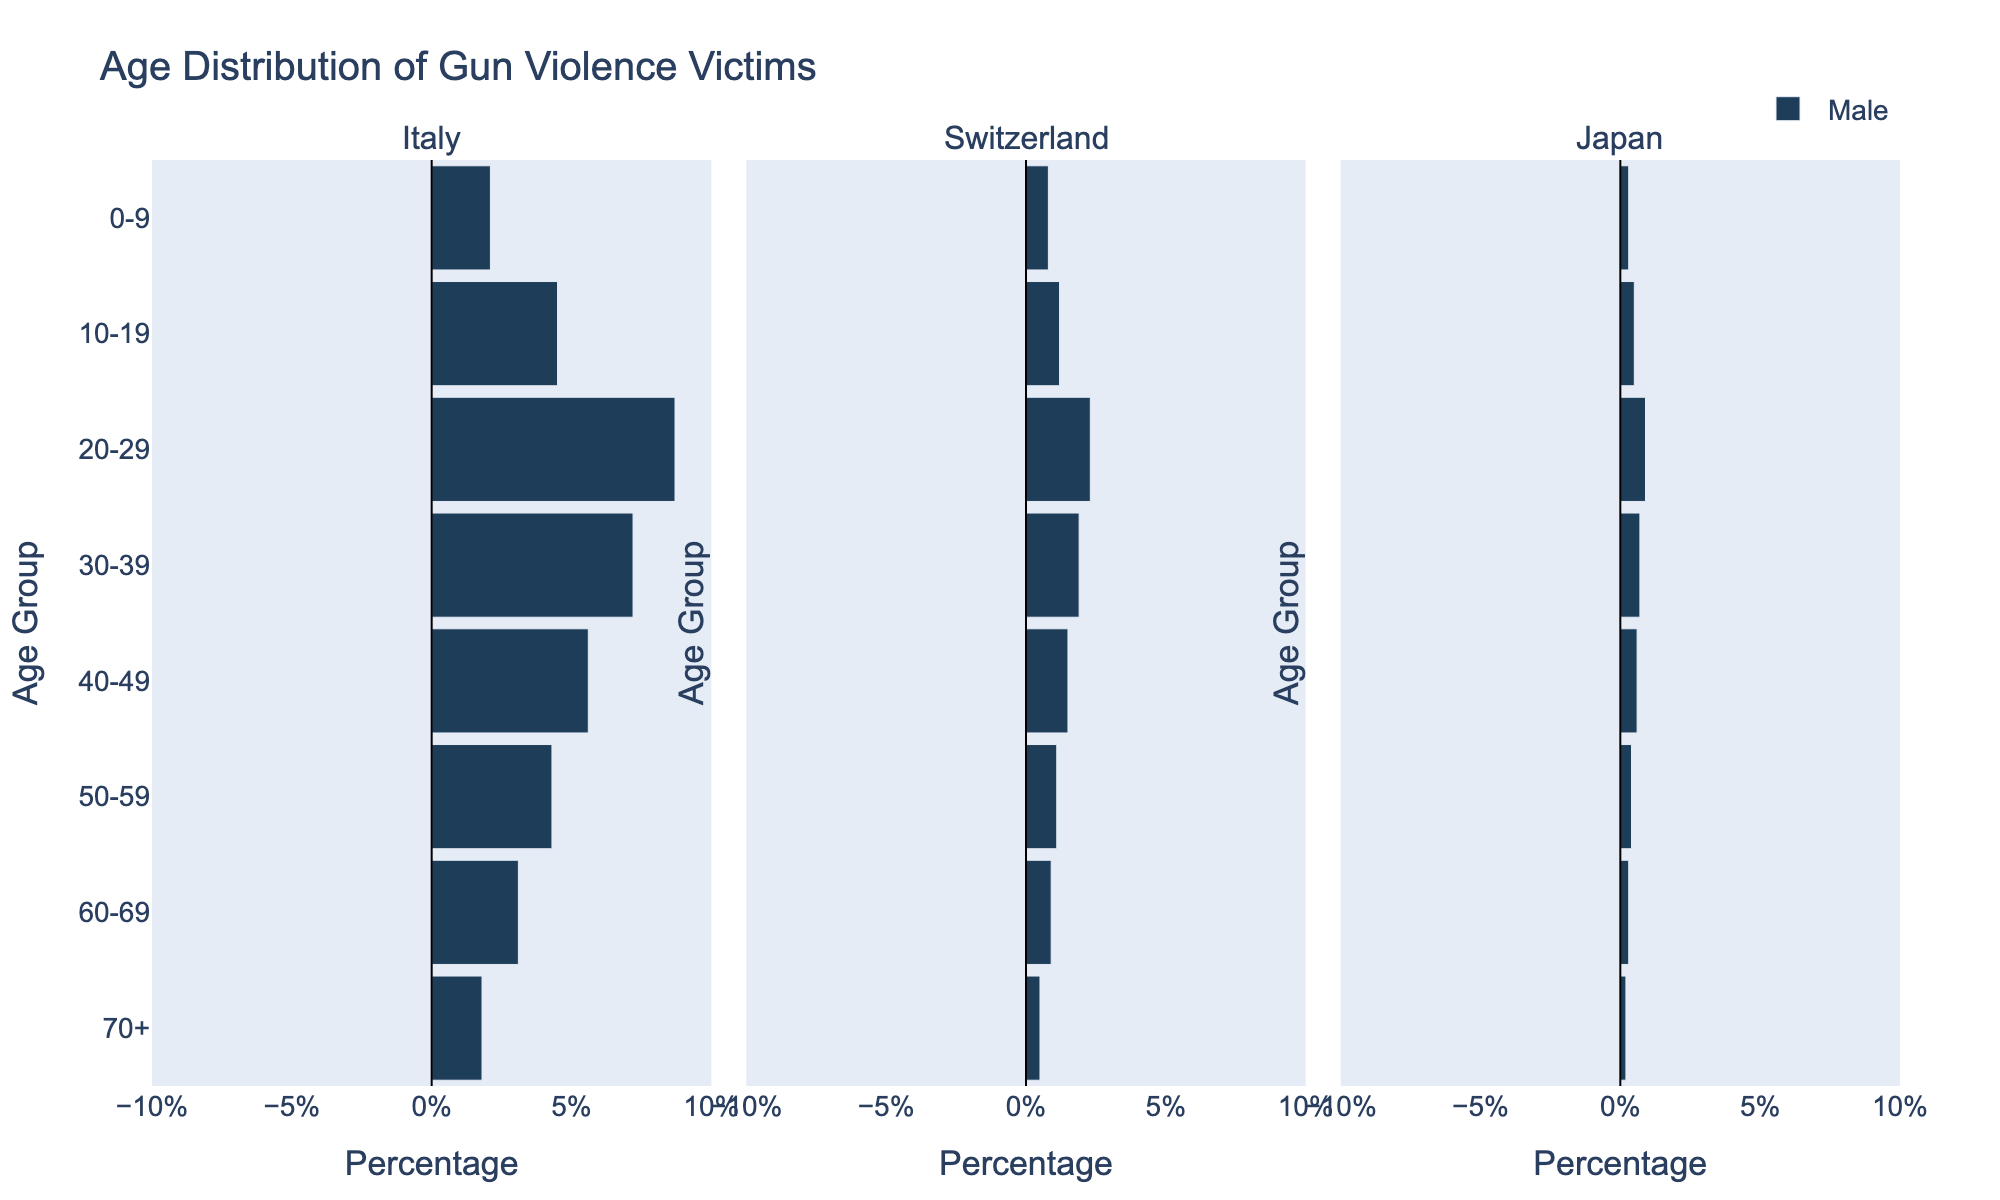What is the title of the figure? The title is often placed at the top of the figure. It provides a summary of what the visual information represents. In this case, it states the age distribution of gun violence victims.
Answer: Age Distribution of Gun Violence Victims Which age group has the highest percentage of male gun violence victims in Italy? Look at the bars on the left side of the Italy subplot. Identify the longest bar to determine the age group with the highest percentage of male victims.
Answer: 20-29 How do the percentages of male gun violence victims in Japan and Switzerland in the 50-59 age group compare? Compare the length of the bars on the left side of the Japan and Switzerland subplots for the 50-59 age group to see which is longer.
Answer: Japan has a lower percentage (0.4%) than Switzerland (1.1%) What is the total percentage of gun violence victims aged 0-9 for both males and females in Italy? Look at the length of the bars for both males and females in the Italy subplot for the age group 0-9, then add their absolute values to get the total.
Answer: 4.1% In which country do we see the smallest percentage of female gun violence victims in the 20-29 age group? Look at the right side of all three subplots, comparing the lengths of the bars within the 20-29 age group to determine the smallest.
Answer: Japan (0.8%) How does the percentage of gun violence victims aged 70+ compare between Italy and Japan? Compare the length of the bars corresponding to the 70+ age group in both Italy and Japan subplots.
Answer: Italy has a higher percentage for both males (-1.8%) and females (1.7%) than Japan (0.2% males, 0.1% females) What can be inferred by comparing the age group 10-19 across all countries? Compare the lengths of the bars corresponding to the 10-19 age group in all three subplots to infer which country has the highest and lowest percentages.
Answer: Italy has the highest (4.5% males, -4.3% females), while Japan has the lowest (0.5% males, -0.4% females) Which country shows the most balanced distribution between male and female gun violence victims? Assess the lengths of the bars for males and females across all age groups within each country subplot to determine which country has closer length bars for both genders.
Answer: Japan 